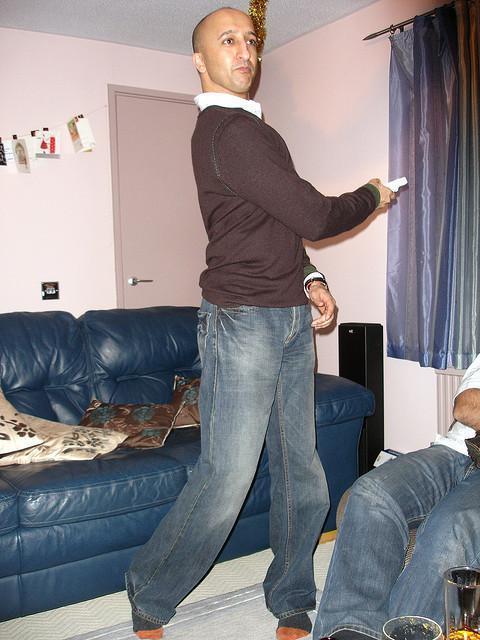What process is used to create the pillow fabric?
Pick the correct solution from the four options below to address the question.
Options: Embroidery, painting, knitting, quilting. Embroidery. 